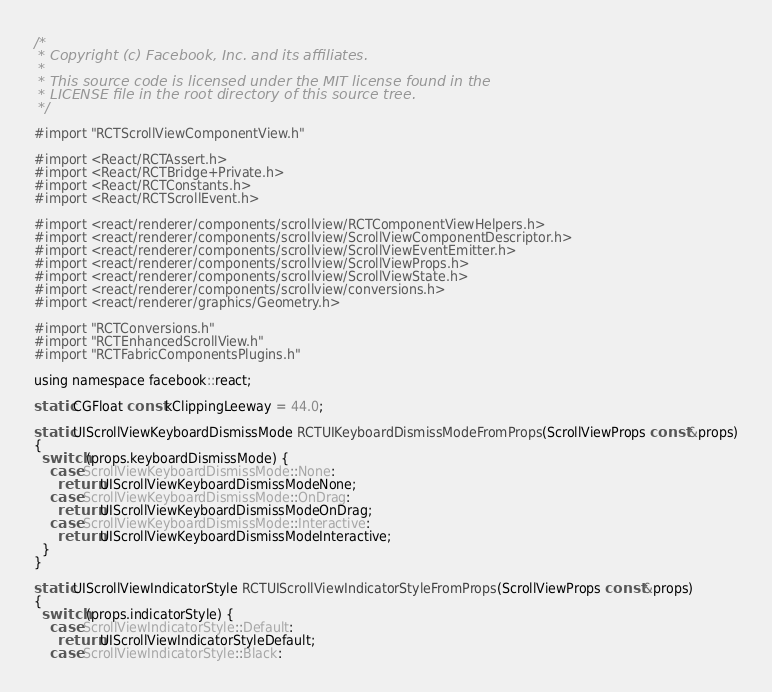<code> <loc_0><loc_0><loc_500><loc_500><_ObjectiveC_>/*
 * Copyright (c) Facebook, Inc. and its affiliates.
 *
 * This source code is licensed under the MIT license found in the
 * LICENSE file in the root directory of this source tree.
 */

#import "RCTScrollViewComponentView.h"

#import <React/RCTAssert.h>
#import <React/RCTBridge+Private.h>
#import <React/RCTConstants.h>
#import <React/RCTScrollEvent.h>

#import <react/renderer/components/scrollview/RCTComponentViewHelpers.h>
#import <react/renderer/components/scrollview/ScrollViewComponentDescriptor.h>
#import <react/renderer/components/scrollview/ScrollViewEventEmitter.h>
#import <react/renderer/components/scrollview/ScrollViewProps.h>
#import <react/renderer/components/scrollview/ScrollViewState.h>
#import <react/renderer/components/scrollview/conversions.h>
#import <react/renderer/graphics/Geometry.h>

#import "RCTConversions.h"
#import "RCTEnhancedScrollView.h"
#import "RCTFabricComponentsPlugins.h"

using namespace facebook::react;

static CGFloat const kClippingLeeway = 44.0;

static UIScrollViewKeyboardDismissMode RCTUIKeyboardDismissModeFromProps(ScrollViewProps const &props)
{
  switch (props.keyboardDismissMode) {
    case ScrollViewKeyboardDismissMode::None:
      return UIScrollViewKeyboardDismissModeNone;
    case ScrollViewKeyboardDismissMode::OnDrag:
      return UIScrollViewKeyboardDismissModeOnDrag;
    case ScrollViewKeyboardDismissMode::Interactive:
      return UIScrollViewKeyboardDismissModeInteractive;
  }
}

static UIScrollViewIndicatorStyle RCTUIScrollViewIndicatorStyleFromProps(ScrollViewProps const &props)
{
  switch (props.indicatorStyle) {
    case ScrollViewIndicatorStyle::Default:
      return UIScrollViewIndicatorStyleDefault;
    case ScrollViewIndicatorStyle::Black:</code> 